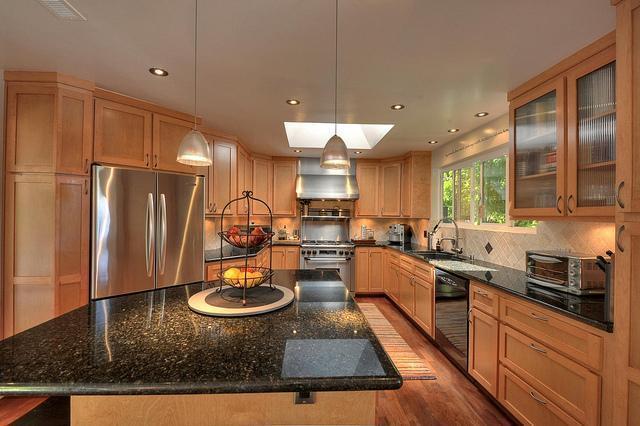How many ovens are there?
Give a very brief answer. 1. 